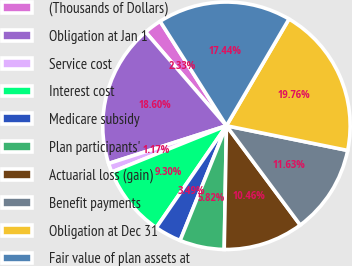Convert chart. <chart><loc_0><loc_0><loc_500><loc_500><pie_chart><fcel>(Thousands of Dollars)<fcel>Obligation at Jan 1<fcel>Service cost<fcel>Interest cost<fcel>Medicare subsidy<fcel>Plan participants'<fcel>Actuarial loss (gain)<fcel>Benefit payments<fcel>Obligation at Dec 31<fcel>Fair value of plan assets at<nl><fcel>2.33%<fcel>18.6%<fcel>1.17%<fcel>9.3%<fcel>3.49%<fcel>5.82%<fcel>10.46%<fcel>11.63%<fcel>19.76%<fcel>17.44%<nl></chart> 